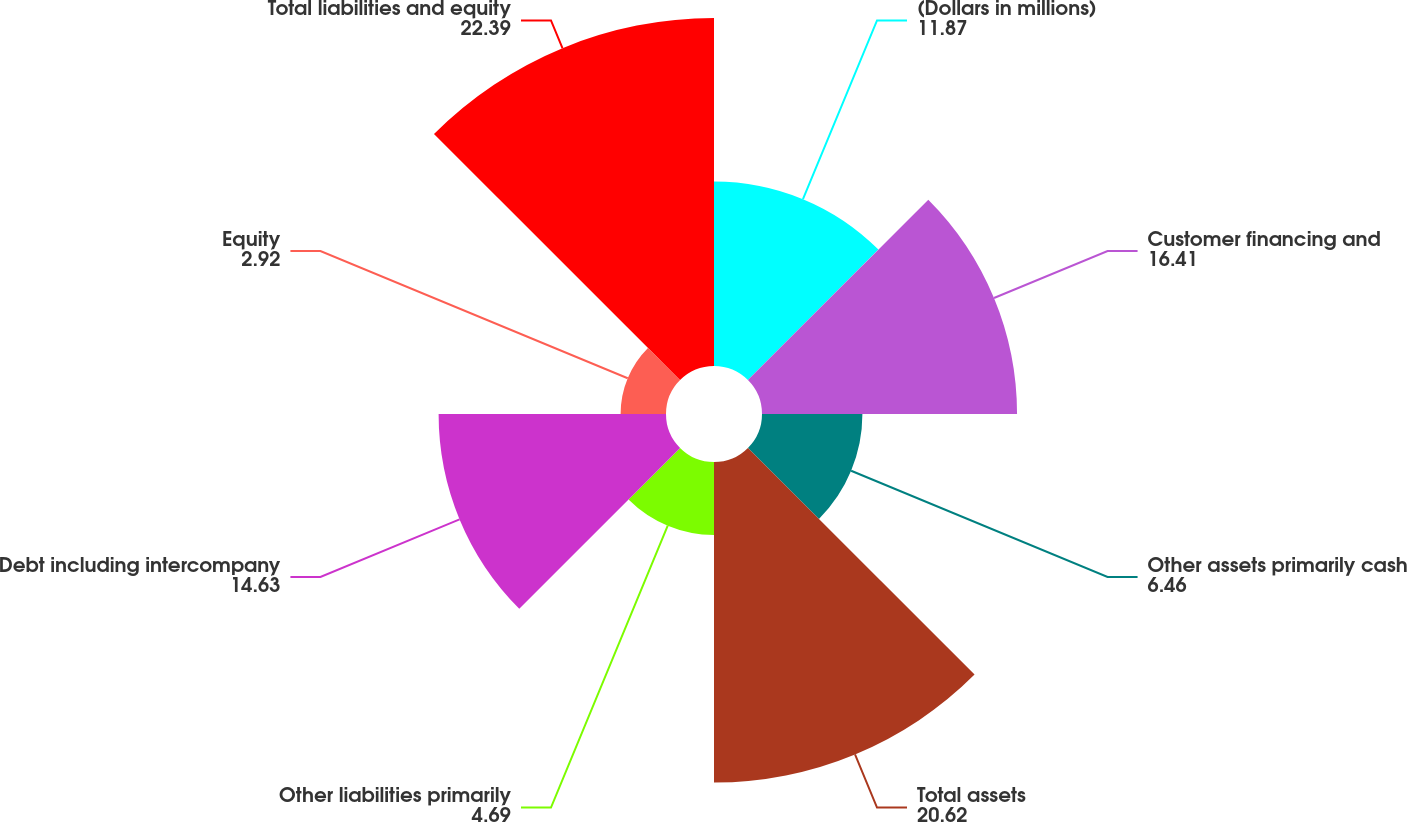Convert chart. <chart><loc_0><loc_0><loc_500><loc_500><pie_chart><fcel>(Dollars in millions)<fcel>Customer financing and<fcel>Other assets primarily cash<fcel>Total assets<fcel>Other liabilities primarily<fcel>Debt including intercompany<fcel>Equity<fcel>Total liabilities and equity<nl><fcel>11.87%<fcel>16.41%<fcel>6.46%<fcel>20.62%<fcel>4.69%<fcel>14.63%<fcel>2.92%<fcel>22.39%<nl></chart> 